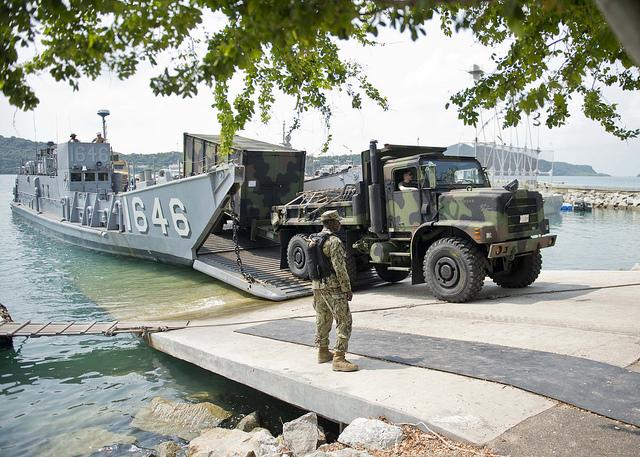Where is this located?
Answer briefly. Army base. What is on the man's back?
Quick response, please. Backpack. How many wheels are visible?
Keep it brief. 3. How many numbers appear on the side of the ship?
Be succinct. 4. Is this a train?
Keep it brief. No. Is the man a soldier?
Answer briefly. Yes. What is the truck doing in the water?
Concise answer only. Loading. Is the back of the truck open or close?
Keep it brief. Open. What is written on the vehicle?
Quick response, please. 1646. 